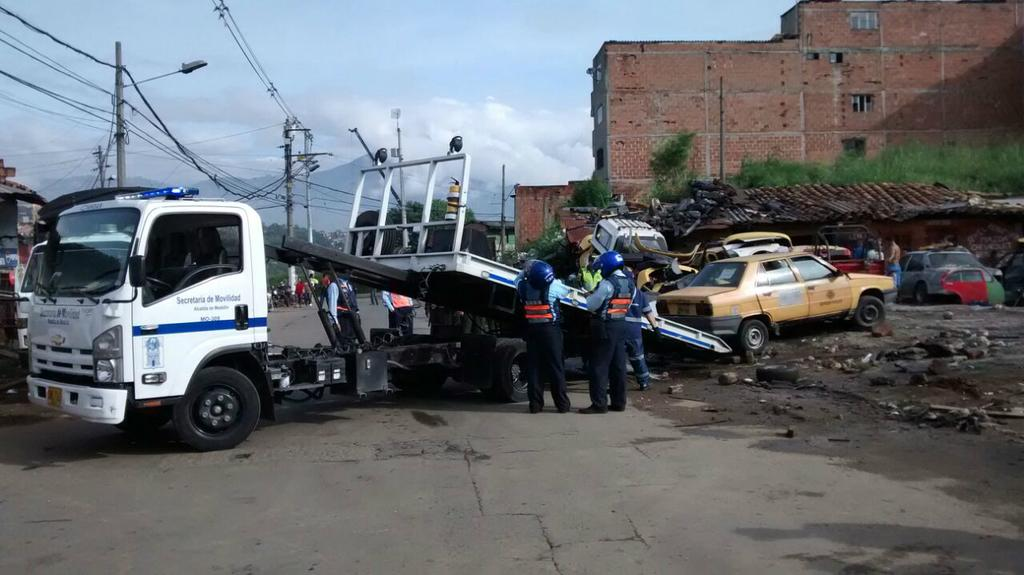What is located in the center of the image? There are vehicles in the center of the image. What are the people in the image wearing? The people in the image are wearing costumes. What can be seen in the background of the image? There are buildings, plants, poles with wires, and the sky visible in the background of the image. What is the weather like in the image? The sky is visible with clouds present, suggesting a partly cloudy day. Can you tell me where the store is located in the image? There is no store present in the image. Are there any fairies visible in the image? There are no fairies present in the image. 